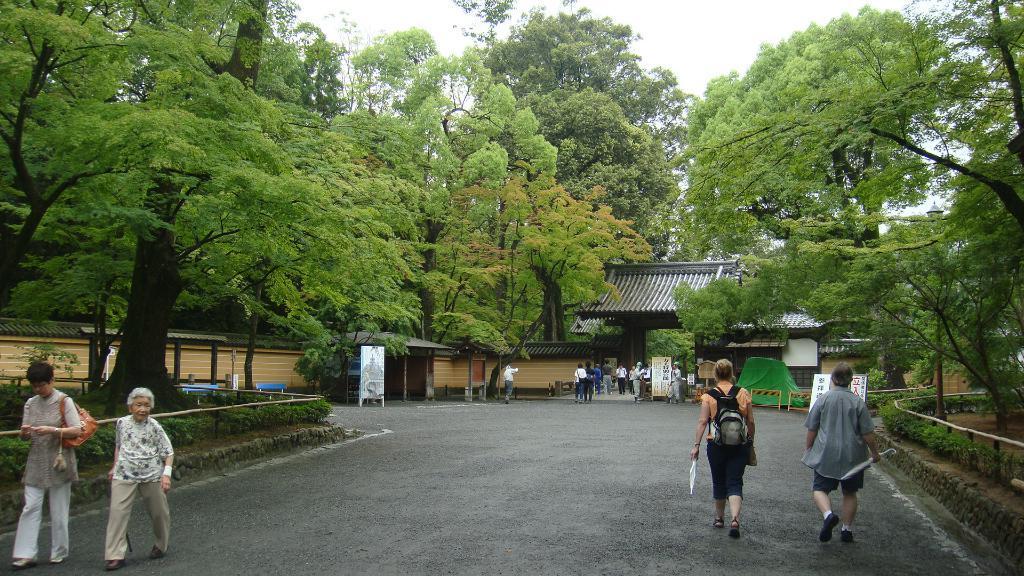Describe this image in one or two sentences. In the foreground of the picture there are people walking down the road. On the right side there are trees, plants and hoarding. On the left there are trees plants and building. In the center of the background there is a building and there are people. Sky is cloudy. 